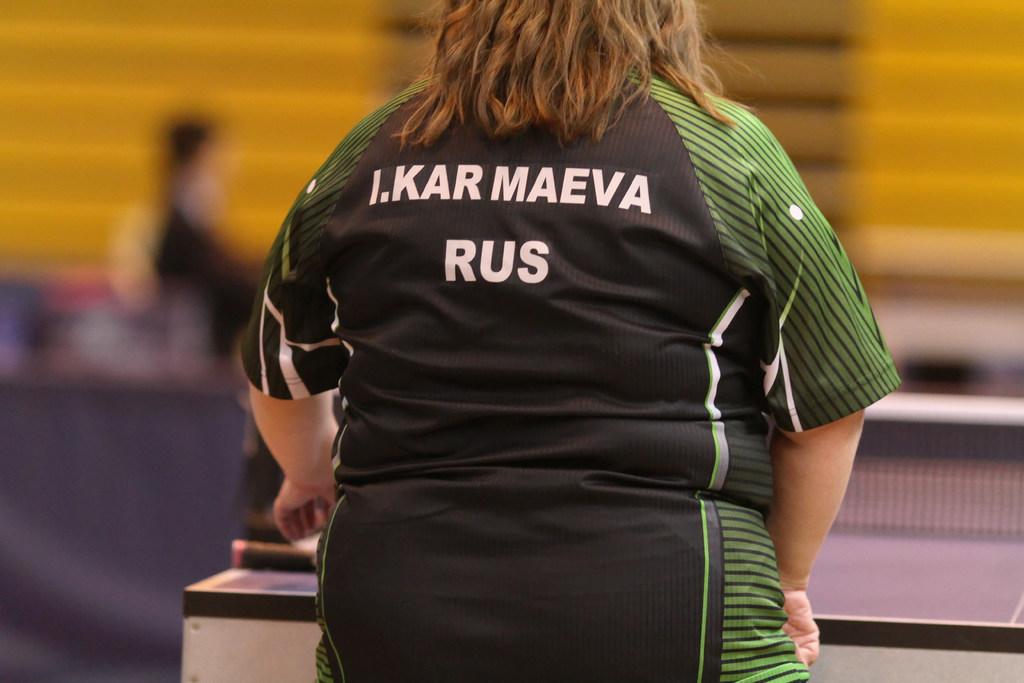Is she over weight?
Your response must be concise. Answering does not require reading text in the image. 